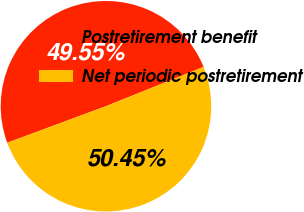Convert chart. <chart><loc_0><loc_0><loc_500><loc_500><pie_chart><fcel>Postretirement benefit<fcel>Net periodic postretirement<nl><fcel>49.55%<fcel>50.45%<nl></chart> 